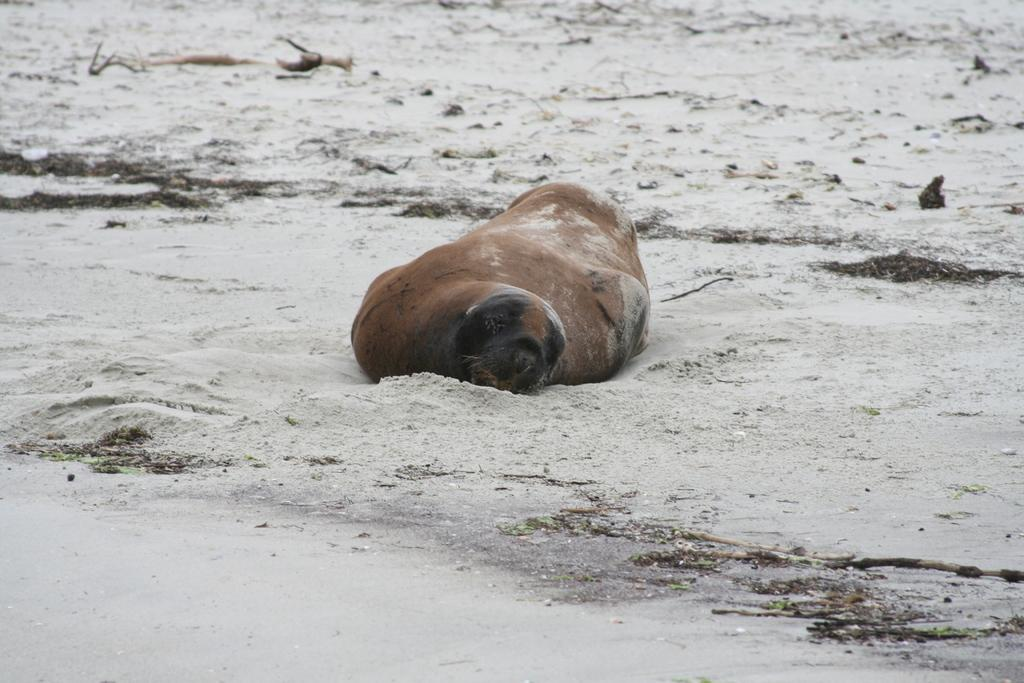What animal is on the ground in the image? There is a seal on the ground in the image. What type of surface is the seal resting on? The ground appears to be sand. Can you describe the background of the image? There is an object visible in the background of the image. What type of punishment is the seal receiving in the image? There is no indication of punishment in the image; the seal is simply resting on the sand. 